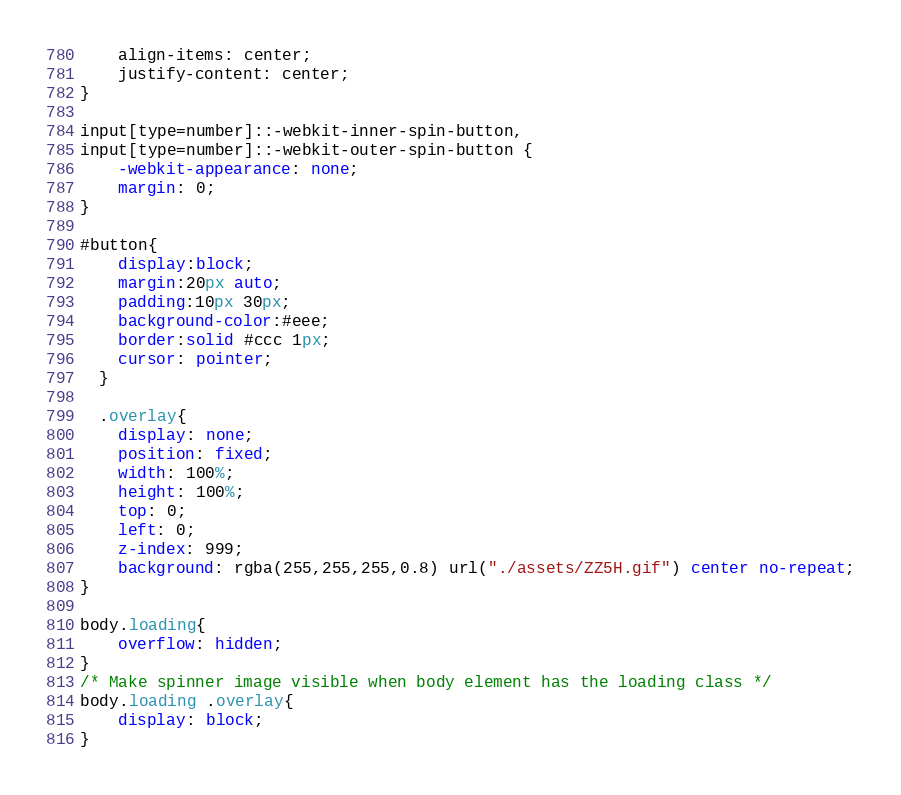<code> <loc_0><loc_0><loc_500><loc_500><_CSS_>    align-items: center;
    justify-content: center;
}

input[type=number]::-webkit-inner-spin-button,
input[type=number]::-webkit-outer-spin-button {
    -webkit-appearance: none;
    margin: 0;
}

#button{
    display:block;
    margin:20px auto;
    padding:10px 30px;
    background-color:#eee;
    border:solid #ccc 1px;
    cursor: pointer;
  }

  .overlay{
    display: none;
    position: fixed;
    width: 100%;
    height: 100%;
    top: 0;
    left: 0;
    z-index: 999;
    background: rgba(255,255,255,0.8) url("./assets/ZZ5H.gif") center no-repeat;
}

body.loading{
    overflow: hidden;   
}
/* Make spinner image visible when body element has the loading class */
body.loading .overlay{
    display: block;
}
</code> 